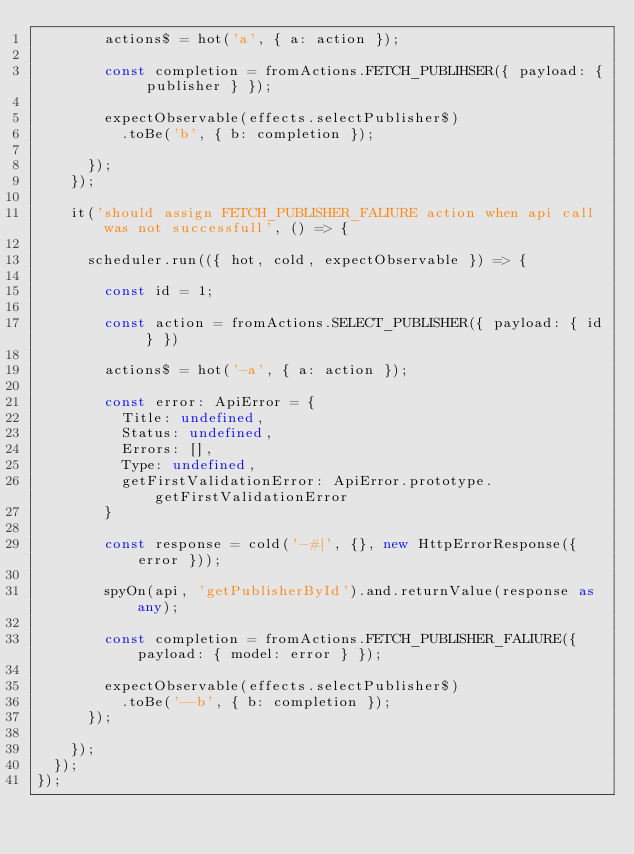Convert code to text. <code><loc_0><loc_0><loc_500><loc_500><_TypeScript_>        actions$ = hot('a', { a: action });

        const completion = fromActions.FETCH_PUBLIHSER({ payload: { publisher } });

        expectObservable(effects.selectPublisher$)
          .toBe('b', { b: completion });

      });
    });

    it('should assign FETCH_PUBLISHER_FALIURE action when api call was not successfull', () => {

      scheduler.run(({ hot, cold, expectObservable }) => {

        const id = 1;

        const action = fromActions.SELECT_PUBLISHER({ payload: { id } })

        actions$ = hot('-a', { a: action });

        const error: ApiError = {
          Title: undefined,
          Status: undefined,
          Errors: [],
          Type: undefined,
          getFirstValidationError: ApiError.prototype.getFirstValidationError
        }

        const response = cold('-#|', {}, new HttpErrorResponse({ error }));

        spyOn(api, 'getPublisherById').and.returnValue(response as any);

        const completion = fromActions.FETCH_PUBLISHER_FALIURE({ payload: { model: error } });

        expectObservable(effects.selectPublisher$)
          .toBe('--b', { b: completion });
      });

    });
  });
});
</code> 